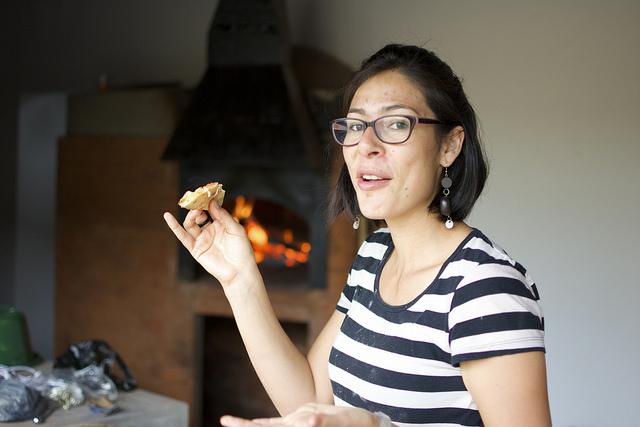What kind of oven is in the background?
Concise answer only. Brick oven. Are there sprinkles on the donut?
Short answer required. No. What pattern is the woman's shirt?
Quick response, please. Striped. How many people are in the shot?
Give a very brief answer. 1. What color is the fire?
Answer briefly. Orange. What is on the woman's neck?
Give a very brief answer. Nothing. What is the woman holding?
Write a very short answer. Pizza. Is someone dreaming of a tropical paradise?
Quick response, please. No. 